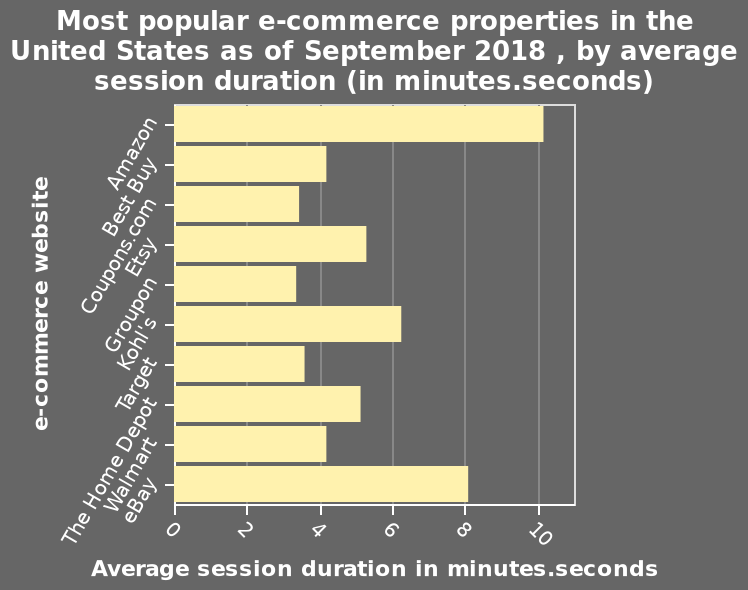<image>
How long does a session last on eBay?  A session on eBay lasts 8 minutes. What is the title of the bar chart?  The title of the bar chart is "Most popular e-commerce properties in the United States as of September 2018, by average session duration (in minutes.seconds)." What does the y-axis represent in the bar chart?  The y-axis represents the e-commerce websites in the bar chart. Offer a thorough analysis of the image. The most popular property is Amazon where an average session lasts 10 minutes. eBay is close behind in popularity with a session lasting 8 minutes. The only other property over 5 minutes duration is Kohl's. Does the x-axis represent the e-commerce websites in the bar chart? No. The y-axis represents the e-commerce websites in the bar chart. 